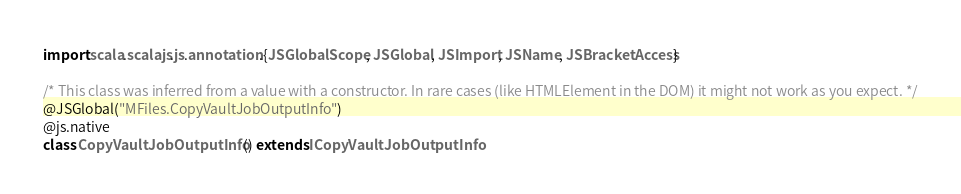<code> <loc_0><loc_0><loc_500><loc_500><_Scala_>import scala.scalajs.js.annotation.{JSGlobalScope, JSGlobal, JSImport, JSName, JSBracketAccess}

/* This class was inferred from a value with a constructor. In rare cases (like HTMLElement in the DOM) it might not work as you expect. */
@JSGlobal("MFiles.CopyVaultJobOutputInfo")
@js.native
class CopyVaultJobOutputInfo () extends ICopyVaultJobOutputInfo
</code> 